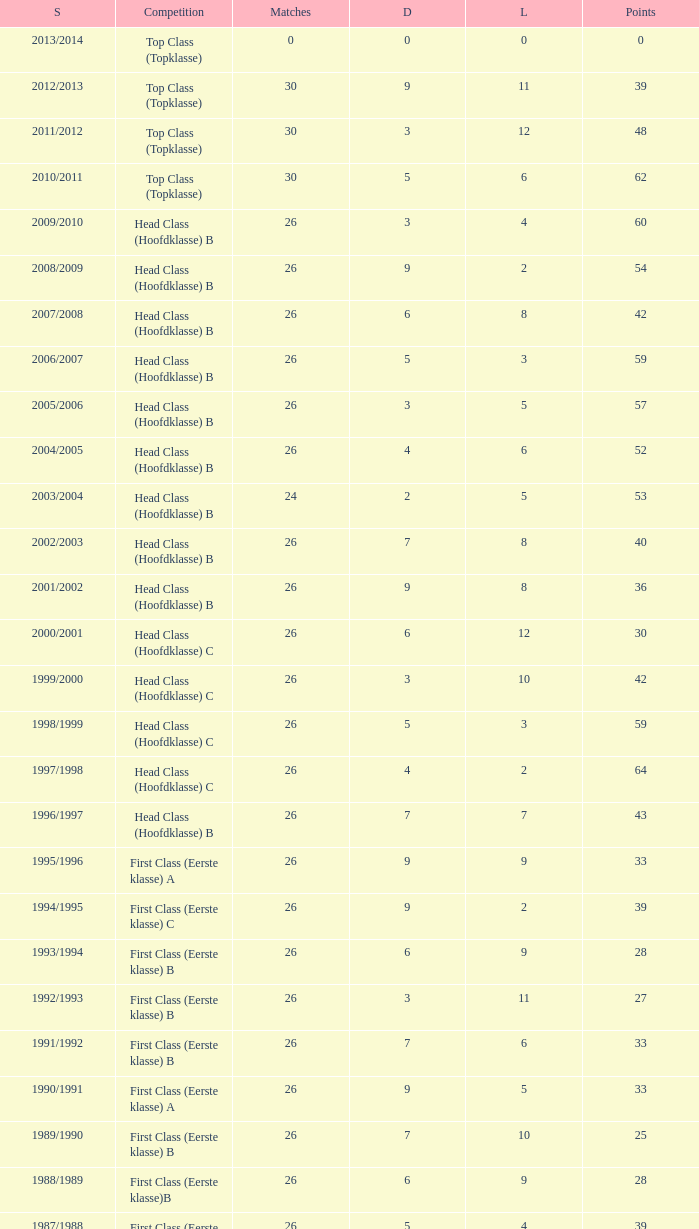What is the sum of the losses that a match score larger than 26, a points score of 62, and a draw greater than 5? None. 